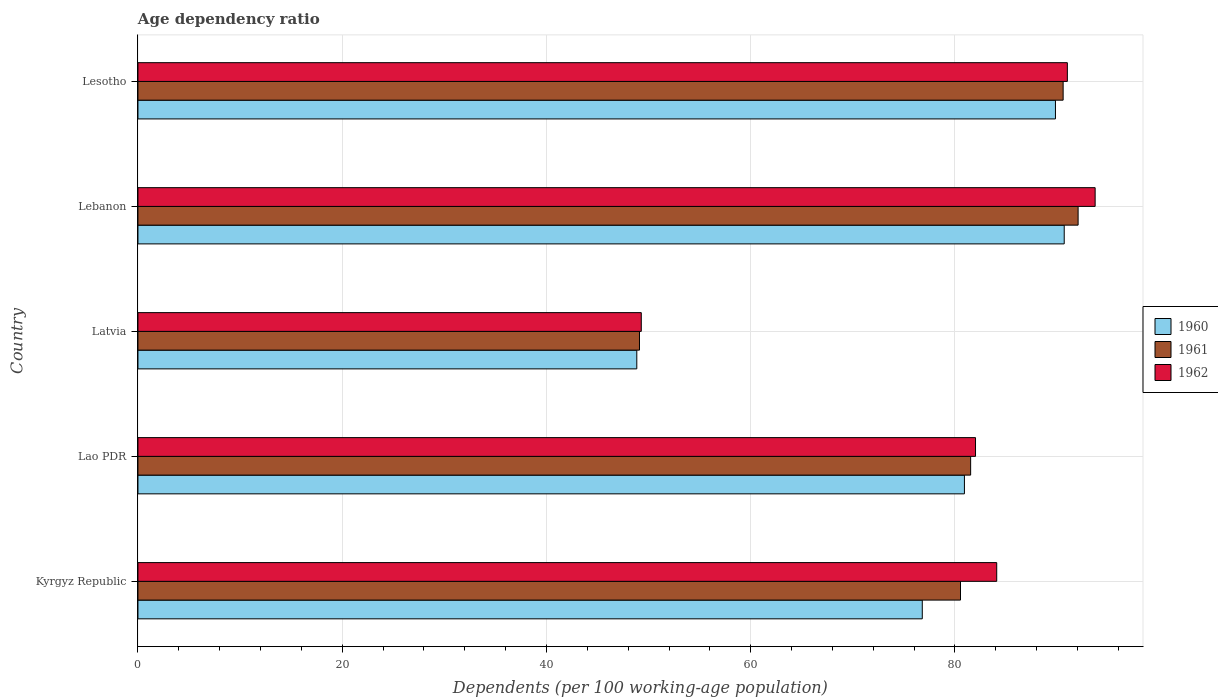How many different coloured bars are there?
Offer a terse response. 3. How many groups of bars are there?
Keep it short and to the point. 5. Are the number of bars per tick equal to the number of legend labels?
Your answer should be compact. Yes. Are the number of bars on each tick of the Y-axis equal?
Offer a very short reply. Yes. What is the label of the 2nd group of bars from the top?
Keep it short and to the point. Lebanon. In how many cases, is the number of bars for a given country not equal to the number of legend labels?
Provide a short and direct response. 0. What is the age dependency ratio in in 1962 in Lebanon?
Your response must be concise. 93.73. Across all countries, what is the maximum age dependency ratio in in 1961?
Offer a very short reply. 92.06. Across all countries, what is the minimum age dependency ratio in in 1960?
Your response must be concise. 48.85. In which country was the age dependency ratio in in 1960 maximum?
Your answer should be very brief. Lebanon. In which country was the age dependency ratio in in 1962 minimum?
Make the answer very short. Latvia. What is the total age dependency ratio in in 1960 in the graph?
Provide a short and direct response. 387.11. What is the difference between the age dependency ratio in in 1960 in Latvia and that in Lesotho?
Provide a short and direct response. -40.99. What is the difference between the age dependency ratio in in 1962 in Lesotho and the age dependency ratio in in 1960 in Lebanon?
Provide a short and direct response. 0.31. What is the average age dependency ratio in in 1961 per country?
Keep it short and to the point. 78.77. What is the difference between the age dependency ratio in in 1961 and age dependency ratio in in 1960 in Lao PDR?
Provide a short and direct response. 0.61. In how many countries, is the age dependency ratio in in 1960 greater than 64 %?
Keep it short and to the point. 4. What is the ratio of the age dependency ratio in in 1960 in Lao PDR to that in Lesotho?
Offer a terse response. 0.9. What is the difference between the highest and the second highest age dependency ratio in in 1961?
Your answer should be very brief. 1.47. What is the difference between the highest and the lowest age dependency ratio in in 1962?
Keep it short and to the point. 44.44. In how many countries, is the age dependency ratio in in 1960 greater than the average age dependency ratio in in 1960 taken over all countries?
Offer a terse response. 3. Is the sum of the age dependency ratio in in 1961 in Latvia and Lebanon greater than the maximum age dependency ratio in in 1960 across all countries?
Your answer should be compact. Yes. What does the 1st bar from the bottom in Lesotho represents?
Offer a terse response. 1960. Are the values on the major ticks of X-axis written in scientific E-notation?
Your answer should be very brief. No. Does the graph contain grids?
Make the answer very short. Yes. Where does the legend appear in the graph?
Provide a short and direct response. Center right. What is the title of the graph?
Make the answer very short. Age dependency ratio. Does "1993" appear as one of the legend labels in the graph?
Keep it short and to the point. No. What is the label or title of the X-axis?
Ensure brevity in your answer.  Dependents (per 100 working-age population). What is the label or title of the Y-axis?
Your answer should be compact. Country. What is the Dependents (per 100 working-age population) in 1960 in Kyrgyz Republic?
Ensure brevity in your answer.  76.8. What is the Dependents (per 100 working-age population) in 1961 in Kyrgyz Republic?
Ensure brevity in your answer.  80.54. What is the Dependents (per 100 working-age population) in 1962 in Kyrgyz Republic?
Your answer should be very brief. 84.09. What is the Dependents (per 100 working-age population) of 1960 in Lao PDR?
Offer a terse response. 80.93. What is the Dependents (per 100 working-age population) of 1961 in Lao PDR?
Provide a short and direct response. 81.54. What is the Dependents (per 100 working-age population) of 1962 in Lao PDR?
Your response must be concise. 82.01. What is the Dependents (per 100 working-age population) of 1960 in Latvia?
Your response must be concise. 48.85. What is the Dependents (per 100 working-age population) in 1961 in Latvia?
Your response must be concise. 49.11. What is the Dependents (per 100 working-age population) of 1962 in Latvia?
Make the answer very short. 49.29. What is the Dependents (per 100 working-age population) in 1960 in Lebanon?
Provide a short and direct response. 90.7. What is the Dependents (per 100 working-age population) in 1961 in Lebanon?
Ensure brevity in your answer.  92.06. What is the Dependents (per 100 working-age population) of 1962 in Lebanon?
Provide a short and direct response. 93.73. What is the Dependents (per 100 working-age population) in 1960 in Lesotho?
Ensure brevity in your answer.  89.84. What is the Dependents (per 100 working-age population) of 1961 in Lesotho?
Provide a succinct answer. 90.59. What is the Dependents (per 100 working-age population) in 1962 in Lesotho?
Your response must be concise. 91.01. Across all countries, what is the maximum Dependents (per 100 working-age population) of 1960?
Give a very brief answer. 90.7. Across all countries, what is the maximum Dependents (per 100 working-age population) of 1961?
Your answer should be very brief. 92.06. Across all countries, what is the maximum Dependents (per 100 working-age population) of 1962?
Make the answer very short. 93.73. Across all countries, what is the minimum Dependents (per 100 working-age population) of 1960?
Provide a succinct answer. 48.85. Across all countries, what is the minimum Dependents (per 100 working-age population) of 1961?
Make the answer very short. 49.11. Across all countries, what is the minimum Dependents (per 100 working-age population) of 1962?
Provide a short and direct response. 49.29. What is the total Dependents (per 100 working-age population) of 1960 in the graph?
Your answer should be very brief. 387.11. What is the total Dependents (per 100 working-age population) of 1961 in the graph?
Offer a terse response. 393.84. What is the total Dependents (per 100 working-age population) in 1962 in the graph?
Your response must be concise. 400.12. What is the difference between the Dependents (per 100 working-age population) of 1960 in Kyrgyz Republic and that in Lao PDR?
Make the answer very short. -4.13. What is the difference between the Dependents (per 100 working-age population) in 1961 in Kyrgyz Republic and that in Lao PDR?
Keep it short and to the point. -0.99. What is the difference between the Dependents (per 100 working-age population) of 1962 in Kyrgyz Republic and that in Lao PDR?
Your answer should be compact. 2.08. What is the difference between the Dependents (per 100 working-age population) of 1960 in Kyrgyz Republic and that in Latvia?
Ensure brevity in your answer.  27.95. What is the difference between the Dependents (per 100 working-age population) in 1961 in Kyrgyz Republic and that in Latvia?
Keep it short and to the point. 31.43. What is the difference between the Dependents (per 100 working-age population) in 1962 in Kyrgyz Republic and that in Latvia?
Give a very brief answer. 34.8. What is the difference between the Dependents (per 100 working-age population) in 1960 in Kyrgyz Republic and that in Lebanon?
Give a very brief answer. -13.9. What is the difference between the Dependents (per 100 working-age population) in 1961 in Kyrgyz Republic and that in Lebanon?
Offer a terse response. -11.52. What is the difference between the Dependents (per 100 working-age population) of 1962 in Kyrgyz Republic and that in Lebanon?
Ensure brevity in your answer.  -9.64. What is the difference between the Dependents (per 100 working-age population) in 1960 in Kyrgyz Republic and that in Lesotho?
Give a very brief answer. -13.04. What is the difference between the Dependents (per 100 working-age population) of 1961 in Kyrgyz Republic and that in Lesotho?
Make the answer very short. -10.05. What is the difference between the Dependents (per 100 working-age population) in 1962 in Kyrgyz Republic and that in Lesotho?
Provide a succinct answer. -6.92. What is the difference between the Dependents (per 100 working-age population) of 1960 in Lao PDR and that in Latvia?
Provide a short and direct response. 32.08. What is the difference between the Dependents (per 100 working-age population) in 1961 in Lao PDR and that in Latvia?
Provide a succinct answer. 32.43. What is the difference between the Dependents (per 100 working-age population) of 1962 in Lao PDR and that in Latvia?
Provide a short and direct response. 32.73. What is the difference between the Dependents (per 100 working-age population) of 1960 in Lao PDR and that in Lebanon?
Your answer should be compact. -9.77. What is the difference between the Dependents (per 100 working-age population) of 1961 in Lao PDR and that in Lebanon?
Your answer should be very brief. -10.52. What is the difference between the Dependents (per 100 working-age population) in 1962 in Lao PDR and that in Lebanon?
Offer a terse response. -11.71. What is the difference between the Dependents (per 100 working-age population) of 1960 in Lao PDR and that in Lesotho?
Your response must be concise. -8.92. What is the difference between the Dependents (per 100 working-age population) in 1961 in Lao PDR and that in Lesotho?
Offer a terse response. -9.06. What is the difference between the Dependents (per 100 working-age population) in 1962 in Lao PDR and that in Lesotho?
Your response must be concise. -8.99. What is the difference between the Dependents (per 100 working-age population) of 1960 in Latvia and that in Lebanon?
Your answer should be compact. -41.85. What is the difference between the Dependents (per 100 working-age population) of 1961 in Latvia and that in Lebanon?
Provide a short and direct response. -42.95. What is the difference between the Dependents (per 100 working-age population) in 1962 in Latvia and that in Lebanon?
Your response must be concise. -44.44. What is the difference between the Dependents (per 100 working-age population) in 1960 in Latvia and that in Lesotho?
Make the answer very short. -40.99. What is the difference between the Dependents (per 100 working-age population) of 1961 in Latvia and that in Lesotho?
Keep it short and to the point. -41.48. What is the difference between the Dependents (per 100 working-age population) in 1962 in Latvia and that in Lesotho?
Your answer should be compact. -41.72. What is the difference between the Dependents (per 100 working-age population) in 1961 in Lebanon and that in Lesotho?
Your response must be concise. 1.47. What is the difference between the Dependents (per 100 working-age population) of 1962 in Lebanon and that in Lesotho?
Provide a short and direct response. 2.72. What is the difference between the Dependents (per 100 working-age population) of 1960 in Kyrgyz Republic and the Dependents (per 100 working-age population) of 1961 in Lao PDR?
Your answer should be very brief. -4.74. What is the difference between the Dependents (per 100 working-age population) of 1960 in Kyrgyz Republic and the Dependents (per 100 working-age population) of 1962 in Lao PDR?
Provide a short and direct response. -5.21. What is the difference between the Dependents (per 100 working-age population) of 1961 in Kyrgyz Republic and the Dependents (per 100 working-age population) of 1962 in Lao PDR?
Your answer should be compact. -1.47. What is the difference between the Dependents (per 100 working-age population) of 1960 in Kyrgyz Republic and the Dependents (per 100 working-age population) of 1961 in Latvia?
Offer a terse response. 27.69. What is the difference between the Dependents (per 100 working-age population) in 1960 in Kyrgyz Republic and the Dependents (per 100 working-age population) in 1962 in Latvia?
Your answer should be compact. 27.51. What is the difference between the Dependents (per 100 working-age population) of 1961 in Kyrgyz Republic and the Dependents (per 100 working-age population) of 1962 in Latvia?
Your response must be concise. 31.26. What is the difference between the Dependents (per 100 working-age population) of 1960 in Kyrgyz Republic and the Dependents (per 100 working-age population) of 1961 in Lebanon?
Your answer should be compact. -15.26. What is the difference between the Dependents (per 100 working-age population) in 1960 in Kyrgyz Republic and the Dependents (per 100 working-age population) in 1962 in Lebanon?
Give a very brief answer. -16.93. What is the difference between the Dependents (per 100 working-age population) in 1961 in Kyrgyz Republic and the Dependents (per 100 working-age population) in 1962 in Lebanon?
Make the answer very short. -13.18. What is the difference between the Dependents (per 100 working-age population) in 1960 in Kyrgyz Republic and the Dependents (per 100 working-age population) in 1961 in Lesotho?
Offer a very short reply. -13.79. What is the difference between the Dependents (per 100 working-age population) in 1960 in Kyrgyz Republic and the Dependents (per 100 working-age population) in 1962 in Lesotho?
Make the answer very short. -14.21. What is the difference between the Dependents (per 100 working-age population) in 1961 in Kyrgyz Republic and the Dependents (per 100 working-age population) in 1962 in Lesotho?
Offer a very short reply. -10.46. What is the difference between the Dependents (per 100 working-age population) of 1960 in Lao PDR and the Dependents (per 100 working-age population) of 1961 in Latvia?
Provide a short and direct response. 31.82. What is the difference between the Dependents (per 100 working-age population) of 1960 in Lao PDR and the Dependents (per 100 working-age population) of 1962 in Latvia?
Give a very brief answer. 31.64. What is the difference between the Dependents (per 100 working-age population) of 1961 in Lao PDR and the Dependents (per 100 working-age population) of 1962 in Latvia?
Your answer should be compact. 32.25. What is the difference between the Dependents (per 100 working-age population) in 1960 in Lao PDR and the Dependents (per 100 working-age population) in 1961 in Lebanon?
Offer a very short reply. -11.13. What is the difference between the Dependents (per 100 working-age population) in 1961 in Lao PDR and the Dependents (per 100 working-age population) in 1962 in Lebanon?
Your response must be concise. -12.19. What is the difference between the Dependents (per 100 working-age population) of 1960 in Lao PDR and the Dependents (per 100 working-age population) of 1961 in Lesotho?
Make the answer very short. -9.67. What is the difference between the Dependents (per 100 working-age population) in 1960 in Lao PDR and the Dependents (per 100 working-age population) in 1962 in Lesotho?
Your response must be concise. -10.08. What is the difference between the Dependents (per 100 working-age population) in 1961 in Lao PDR and the Dependents (per 100 working-age population) in 1962 in Lesotho?
Provide a succinct answer. -9.47. What is the difference between the Dependents (per 100 working-age population) of 1960 in Latvia and the Dependents (per 100 working-age population) of 1961 in Lebanon?
Keep it short and to the point. -43.21. What is the difference between the Dependents (per 100 working-age population) of 1960 in Latvia and the Dependents (per 100 working-age population) of 1962 in Lebanon?
Your answer should be very brief. -44.88. What is the difference between the Dependents (per 100 working-age population) in 1961 in Latvia and the Dependents (per 100 working-age population) in 1962 in Lebanon?
Your answer should be very brief. -44.62. What is the difference between the Dependents (per 100 working-age population) of 1960 in Latvia and the Dependents (per 100 working-age population) of 1961 in Lesotho?
Offer a very short reply. -41.75. What is the difference between the Dependents (per 100 working-age population) of 1960 in Latvia and the Dependents (per 100 working-age population) of 1962 in Lesotho?
Your answer should be compact. -42.16. What is the difference between the Dependents (per 100 working-age population) in 1961 in Latvia and the Dependents (per 100 working-age population) in 1962 in Lesotho?
Your response must be concise. -41.9. What is the difference between the Dependents (per 100 working-age population) in 1960 in Lebanon and the Dependents (per 100 working-age population) in 1961 in Lesotho?
Your answer should be very brief. 0.11. What is the difference between the Dependents (per 100 working-age population) in 1960 in Lebanon and the Dependents (per 100 working-age population) in 1962 in Lesotho?
Provide a short and direct response. -0.31. What is the difference between the Dependents (per 100 working-age population) in 1961 in Lebanon and the Dependents (per 100 working-age population) in 1962 in Lesotho?
Keep it short and to the point. 1.05. What is the average Dependents (per 100 working-age population) of 1960 per country?
Your answer should be very brief. 77.42. What is the average Dependents (per 100 working-age population) of 1961 per country?
Your answer should be very brief. 78.77. What is the average Dependents (per 100 working-age population) of 1962 per country?
Your response must be concise. 80.02. What is the difference between the Dependents (per 100 working-age population) of 1960 and Dependents (per 100 working-age population) of 1961 in Kyrgyz Republic?
Make the answer very short. -3.74. What is the difference between the Dependents (per 100 working-age population) in 1960 and Dependents (per 100 working-age population) in 1962 in Kyrgyz Republic?
Give a very brief answer. -7.29. What is the difference between the Dependents (per 100 working-age population) in 1961 and Dependents (per 100 working-age population) in 1962 in Kyrgyz Republic?
Provide a succinct answer. -3.55. What is the difference between the Dependents (per 100 working-age population) in 1960 and Dependents (per 100 working-age population) in 1961 in Lao PDR?
Your answer should be very brief. -0.61. What is the difference between the Dependents (per 100 working-age population) in 1960 and Dependents (per 100 working-age population) in 1962 in Lao PDR?
Give a very brief answer. -1.09. What is the difference between the Dependents (per 100 working-age population) of 1961 and Dependents (per 100 working-age population) of 1962 in Lao PDR?
Give a very brief answer. -0.48. What is the difference between the Dependents (per 100 working-age population) in 1960 and Dependents (per 100 working-age population) in 1961 in Latvia?
Make the answer very short. -0.26. What is the difference between the Dependents (per 100 working-age population) of 1960 and Dependents (per 100 working-age population) of 1962 in Latvia?
Your response must be concise. -0.44. What is the difference between the Dependents (per 100 working-age population) of 1961 and Dependents (per 100 working-age population) of 1962 in Latvia?
Your answer should be very brief. -0.18. What is the difference between the Dependents (per 100 working-age population) in 1960 and Dependents (per 100 working-age population) in 1961 in Lebanon?
Ensure brevity in your answer.  -1.36. What is the difference between the Dependents (per 100 working-age population) in 1960 and Dependents (per 100 working-age population) in 1962 in Lebanon?
Your answer should be very brief. -3.03. What is the difference between the Dependents (per 100 working-age population) of 1961 and Dependents (per 100 working-age population) of 1962 in Lebanon?
Provide a short and direct response. -1.67. What is the difference between the Dependents (per 100 working-age population) of 1960 and Dependents (per 100 working-age population) of 1961 in Lesotho?
Ensure brevity in your answer.  -0.75. What is the difference between the Dependents (per 100 working-age population) in 1960 and Dependents (per 100 working-age population) in 1962 in Lesotho?
Your response must be concise. -1.17. What is the difference between the Dependents (per 100 working-age population) in 1961 and Dependents (per 100 working-age population) in 1962 in Lesotho?
Your answer should be very brief. -0.41. What is the ratio of the Dependents (per 100 working-age population) in 1960 in Kyrgyz Republic to that in Lao PDR?
Make the answer very short. 0.95. What is the ratio of the Dependents (per 100 working-age population) in 1961 in Kyrgyz Republic to that in Lao PDR?
Your answer should be compact. 0.99. What is the ratio of the Dependents (per 100 working-age population) of 1962 in Kyrgyz Republic to that in Lao PDR?
Ensure brevity in your answer.  1.03. What is the ratio of the Dependents (per 100 working-age population) in 1960 in Kyrgyz Republic to that in Latvia?
Give a very brief answer. 1.57. What is the ratio of the Dependents (per 100 working-age population) in 1961 in Kyrgyz Republic to that in Latvia?
Ensure brevity in your answer.  1.64. What is the ratio of the Dependents (per 100 working-age population) in 1962 in Kyrgyz Republic to that in Latvia?
Give a very brief answer. 1.71. What is the ratio of the Dependents (per 100 working-age population) of 1960 in Kyrgyz Republic to that in Lebanon?
Your answer should be very brief. 0.85. What is the ratio of the Dependents (per 100 working-age population) in 1961 in Kyrgyz Republic to that in Lebanon?
Give a very brief answer. 0.87. What is the ratio of the Dependents (per 100 working-age population) of 1962 in Kyrgyz Republic to that in Lebanon?
Provide a succinct answer. 0.9. What is the ratio of the Dependents (per 100 working-age population) of 1960 in Kyrgyz Republic to that in Lesotho?
Ensure brevity in your answer.  0.85. What is the ratio of the Dependents (per 100 working-age population) of 1961 in Kyrgyz Republic to that in Lesotho?
Offer a very short reply. 0.89. What is the ratio of the Dependents (per 100 working-age population) in 1962 in Kyrgyz Republic to that in Lesotho?
Provide a succinct answer. 0.92. What is the ratio of the Dependents (per 100 working-age population) of 1960 in Lao PDR to that in Latvia?
Make the answer very short. 1.66. What is the ratio of the Dependents (per 100 working-age population) in 1961 in Lao PDR to that in Latvia?
Your answer should be very brief. 1.66. What is the ratio of the Dependents (per 100 working-age population) of 1962 in Lao PDR to that in Latvia?
Offer a very short reply. 1.66. What is the ratio of the Dependents (per 100 working-age population) of 1960 in Lao PDR to that in Lebanon?
Make the answer very short. 0.89. What is the ratio of the Dependents (per 100 working-age population) of 1961 in Lao PDR to that in Lebanon?
Your answer should be compact. 0.89. What is the ratio of the Dependents (per 100 working-age population) of 1962 in Lao PDR to that in Lebanon?
Make the answer very short. 0.88. What is the ratio of the Dependents (per 100 working-age population) of 1960 in Lao PDR to that in Lesotho?
Make the answer very short. 0.9. What is the ratio of the Dependents (per 100 working-age population) of 1961 in Lao PDR to that in Lesotho?
Offer a very short reply. 0.9. What is the ratio of the Dependents (per 100 working-age population) of 1962 in Lao PDR to that in Lesotho?
Your answer should be very brief. 0.9. What is the ratio of the Dependents (per 100 working-age population) in 1960 in Latvia to that in Lebanon?
Provide a succinct answer. 0.54. What is the ratio of the Dependents (per 100 working-age population) of 1961 in Latvia to that in Lebanon?
Give a very brief answer. 0.53. What is the ratio of the Dependents (per 100 working-age population) in 1962 in Latvia to that in Lebanon?
Provide a succinct answer. 0.53. What is the ratio of the Dependents (per 100 working-age population) of 1960 in Latvia to that in Lesotho?
Give a very brief answer. 0.54. What is the ratio of the Dependents (per 100 working-age population) in 1961 in Latvia to that in Lesotho?
Your answer should be compact. 0.54. What is the ratio of the Dependents (per 100 working-age population) of 1962 in Latvia to that in Lesotho?
Make the answer very short. 0.54. What is the ratio of the Dependents (per 100 working-age population) in 1960 in Lebanon to that in Lesotho?
Give a very brief answer. 1.01. What is the ratio of the Dependents (per 100 working-age population) in 1961 in Lebanon to that in Lesotho?
Your response must be concise. 1.02. What is the ratio of the Dependents (per 100 working-age population) of 1962 in Lebanon to that in Lesotho?
Ensure brevity in your answer.  1.03. What is the difference between the highest and the second highest Dependents (per 100 working-age population) of 1961?
Provide a succinct answer. 1.47. What is the difference between the highest and the second highest Dependents (per 100 working-age population) in 1962?
Your answer should be compact. 2.72. What is the difference between the highest and the lowest Dependents (per 100 working-age population) in 1960?
Offer a terse response. 41.85. What is the difference between the highest and the lowest Dependents (per 100 working-age population) of 1961?
Ensure brevity in your answer.  42.95. What is the difference between the highest and the lowest Dependents (per 100 working-age population) in 1962?
Ensure brevity in your answer.  44.44. 